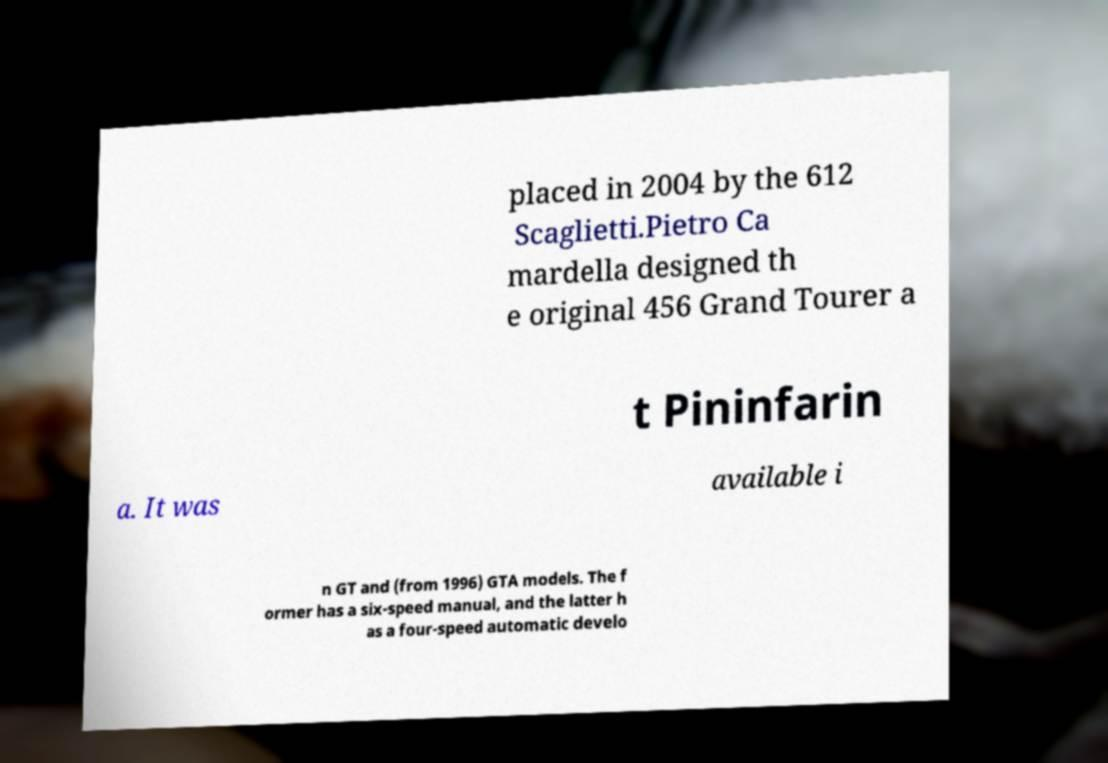There's text embedded in this image that I need extracted. Can you transcribe it verbatim? placed in 2004 by the 612 Scaglietti.Pietro Ca mardella designed th e original 456 Grand Tourer a t Pininfarin a. It was available i n GT and (from 1996) GTA models. The f ormer has a six-speed manual, and the latter h as a four-speed automatic develo 